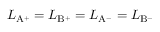Convert formula to latex. <formula><loc_0><loc_0><loc_500><loc_500>L _ { { A ^ { + } } } = L _ { { B ^ { + } } } = L _ { { A ^ { - } } } = L _ { { B ^ { - } } }</formula> 